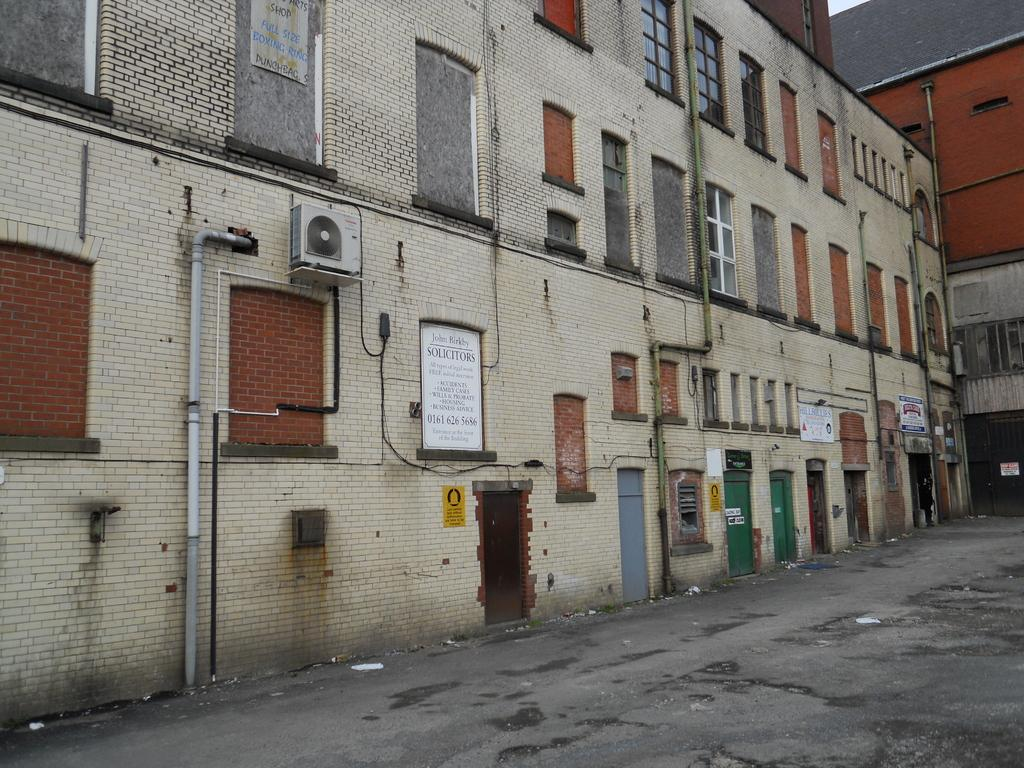What type of structures are present in the image? There are many buildings in the image. What features can be seen on the buildings? The buildings have windows and boards. What can be seen on the ground in the image? There is a path visible in the image. What type of glue is being used to hold the buildings together in the image? There is no glue present in the image; the buildings are likely constructed with traditional building materials. What kind of joke can be seen written on the boards of the buildings in the image? There are no jokes visible on the boards of the buildings in the image. 